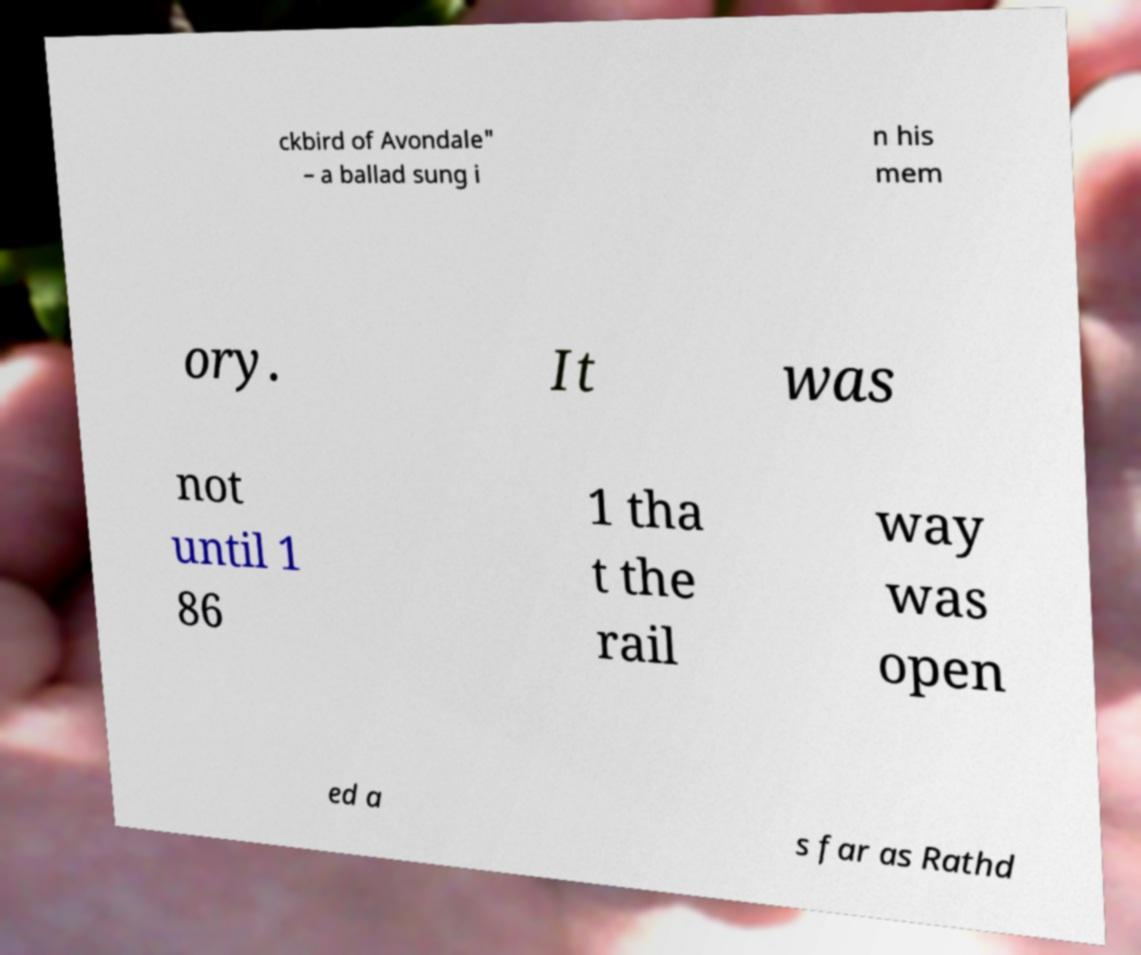Can you accurately transcribe the text from the provided image for me? ckbird of Avondale" – a ballad sung i n his mem ory. It was not until 1 86 1 tha t the rail way was open ed a s far as Rathd 